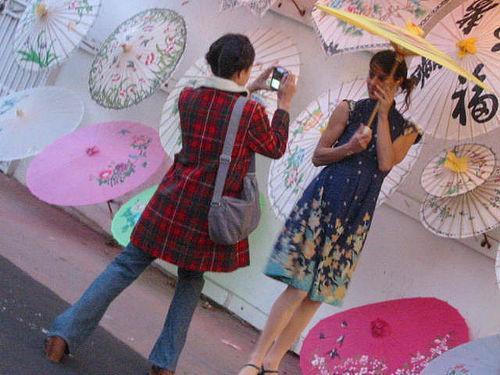How many umbrellas are pink?
Give a very brief answer. 2. How many people are there?
Give a very brief answer. 2. How many umbrellas are in the photo?
Give a very brief answer. 11. How many boats are in the water?
Give a very brief answer. 0. 